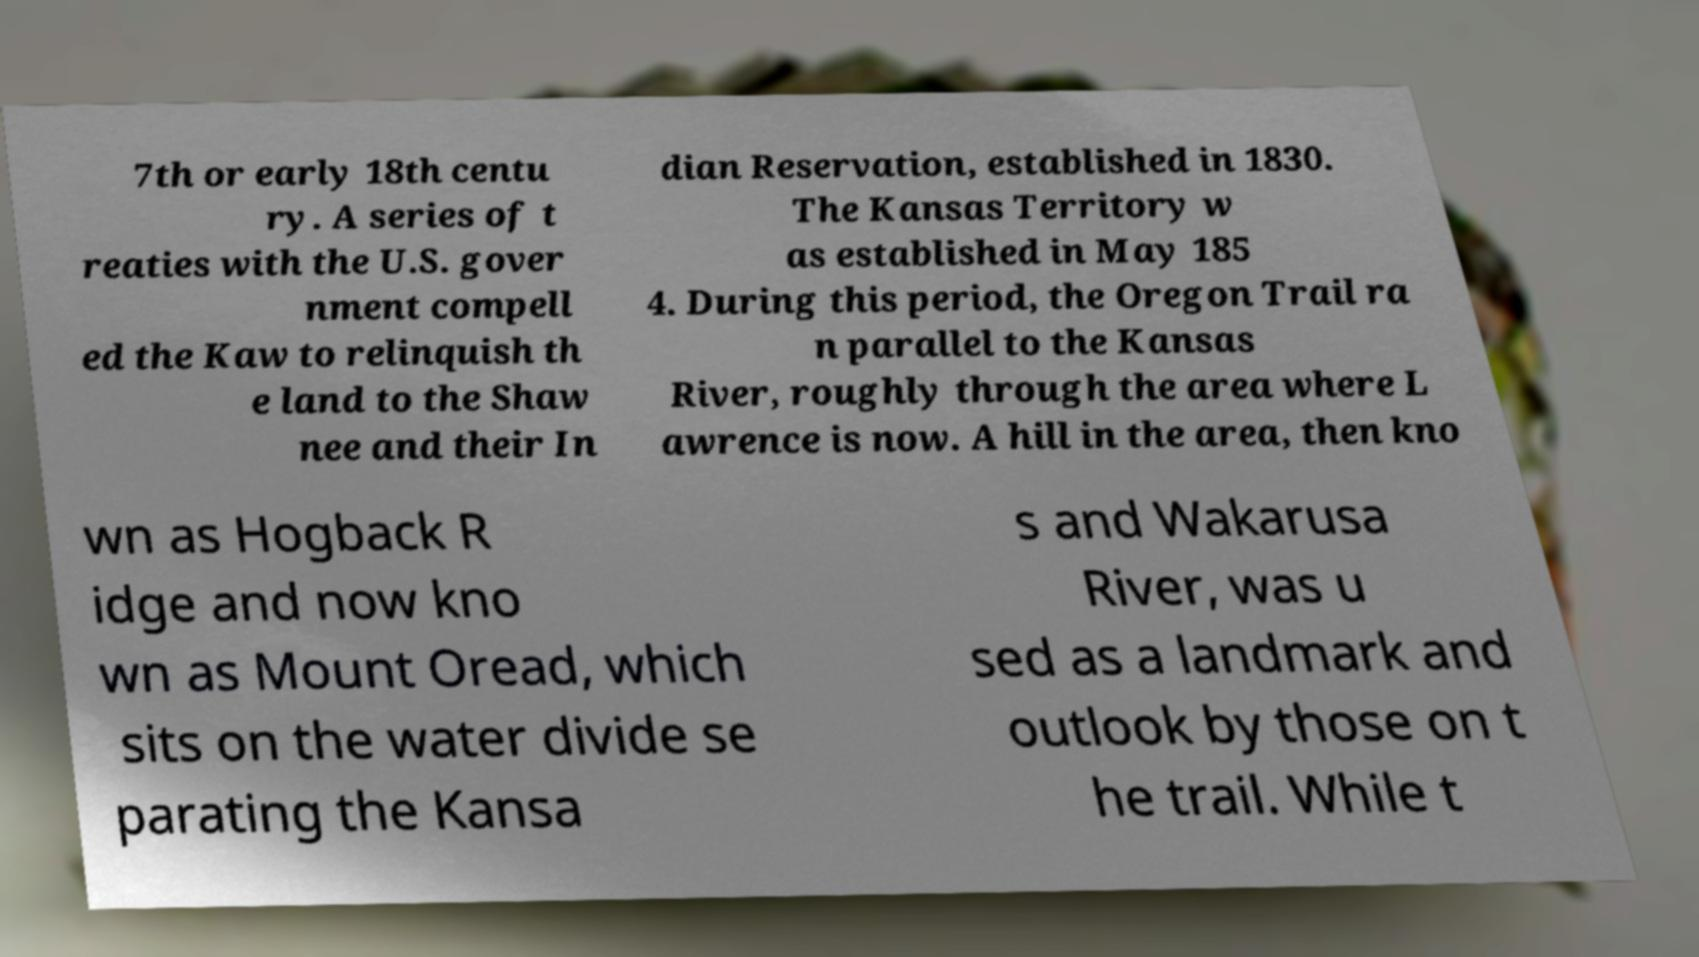I need the written content from this picture converted into text. Can you do that? 7th or early 18th centu ry. A series of t reaties with the U.S. gover nment compell ed the Kaw to relinquish th e land to the Shaw nee and their In dian Reservation, established in 1830. The Kansas Territory w as established in May 185 4. During this period, the Oregon Trail ra n parallel to the Kansas River, roughly through the area where L awrence is now. A hill in the area, then kno wn as Hogback R idge and now kno wn as Mount Oread, which sits on the water divide se parating the Kansa s and Wakarusa River, was u sed as a landmark and outlook by those on t he trail. While t 